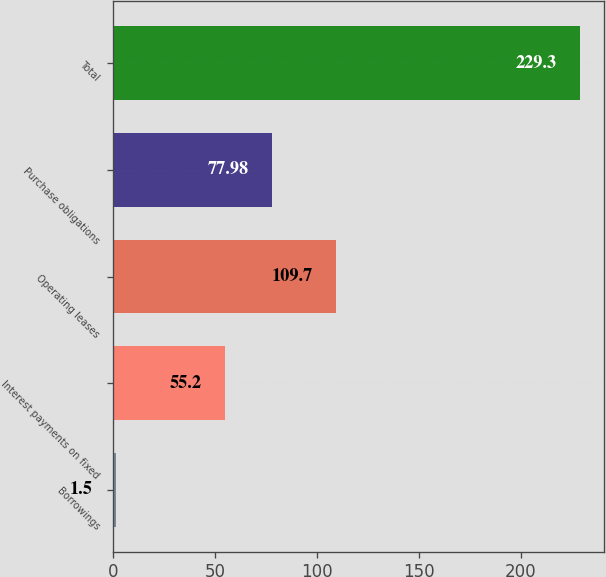Convert chart to OTSL. <chart><loc_0><loc_0><loc_500><loc_500><bar_chart><fcel>Borrowings<fcel>Interest payments on fixed<fcel>Operating leases<fcel>Purchase obligations<fcel>Total<nl><fcel>1.5<fcel>55.2<fcel>109.7<fcel>77.98<fcel>229.3<nl></chart> 